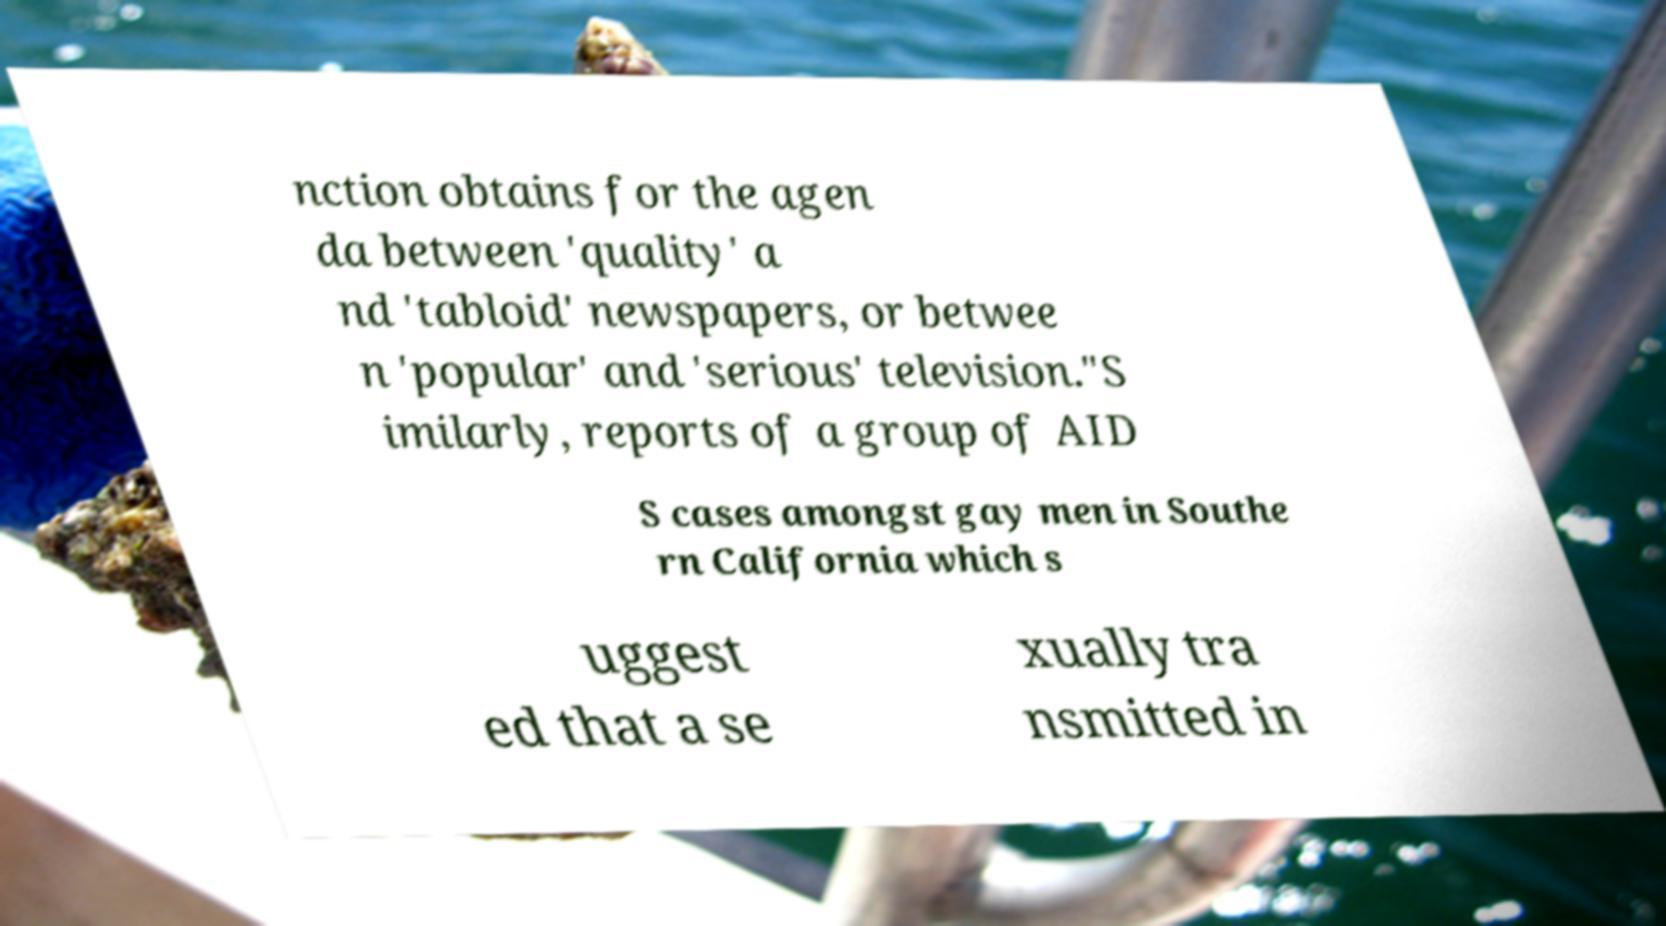Please identify and transcribe the text found in this image. nction obtains for the agen da between 'quality' a nd 'tabloid' newspapers, or betwee n 'popular' and 'serious' television."S imilarly, reports of a group of AID S cases amongst gay men in Southe rn California which s uggest ed that a se xually tra nsmitted in 